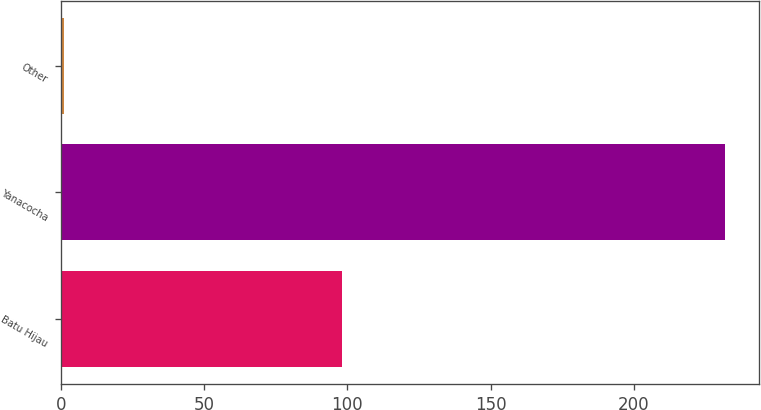Convert chart to OTSL. <chart><loc_0><loc_0><loc_500><loc_500><bar_chart><fcel>Batu Hijau<fcel>Yanacocha<fcel>Other<nl><fcel>98<fcel>232<fcel>1<nl></chart> 